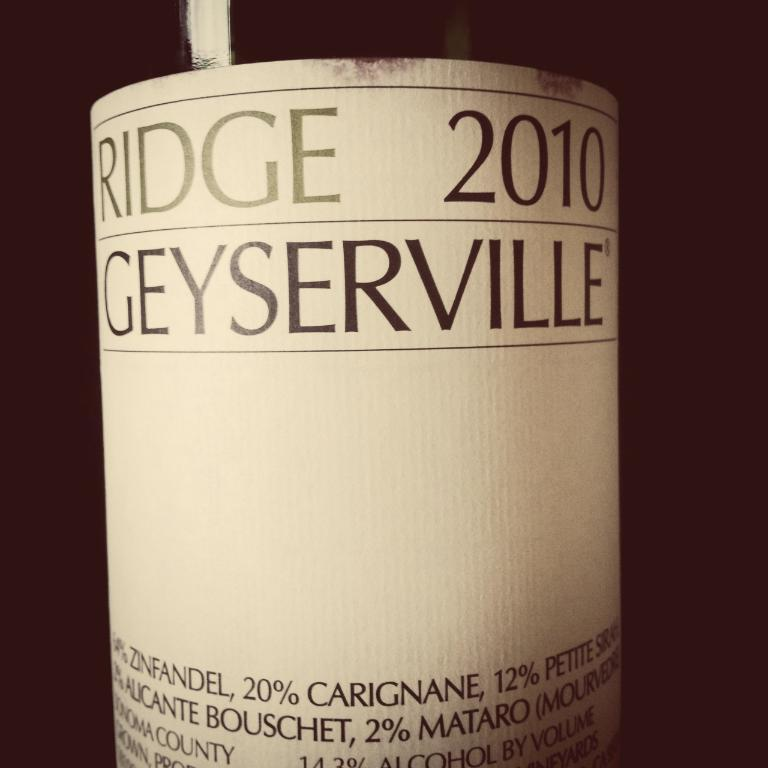<image>
Share a concise interpretation of the image provided. The front label of a bottle of 2010 Ridge Geyserville wine. 